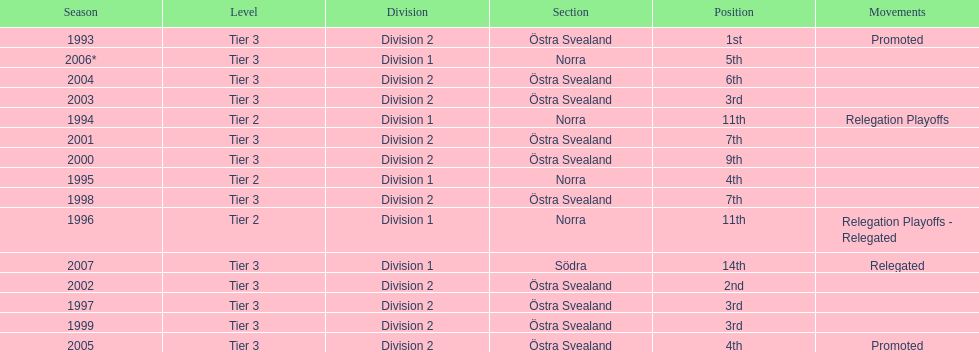In all, how many promotions were given to them? 2. 